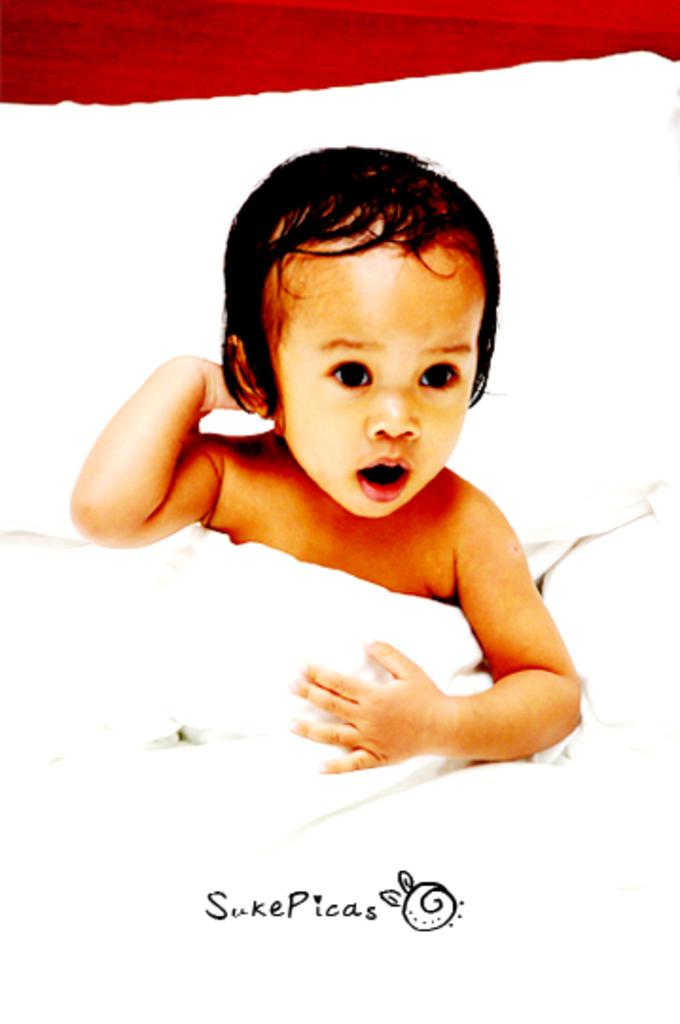What is the main subject of the image? The main subject of the image is a baby. Where is the baby located in the image? The baby is on a bed. Is there any text present in the image? Yes, there is text at the bottom of the image. Can you see a toothbrush being used by the baby in the image? There is no toothbrush visible in the image. What type of whip is being used by the baby in the image? There is no whip present in the image. How many stars can be seen in the image? There are no stars visible in the image. 